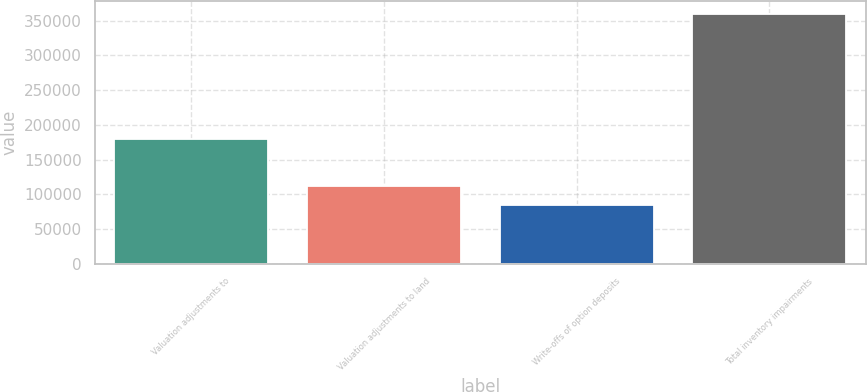Convert chart to OTSL. <chart><loc_0><loc_0><loc_500><loc_500><bar_chart><fcel>Valuation adjustments to<fcel>Valuation adjustments to land<fcel>Write-offs of option deposits<fcel>Total inventory impairments<nl><fcel>180239<fcel>111927<fcel>84372<fcel>359925<nl></chart> 